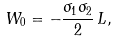Convert formula to latex. <formula><loc_0><loc_0><loc_500><loc_500>W _ { 0 } = - \frac { \sigma _ { 1 } \sigma _ { 2 } } { 2 } \, L ,</formula> 